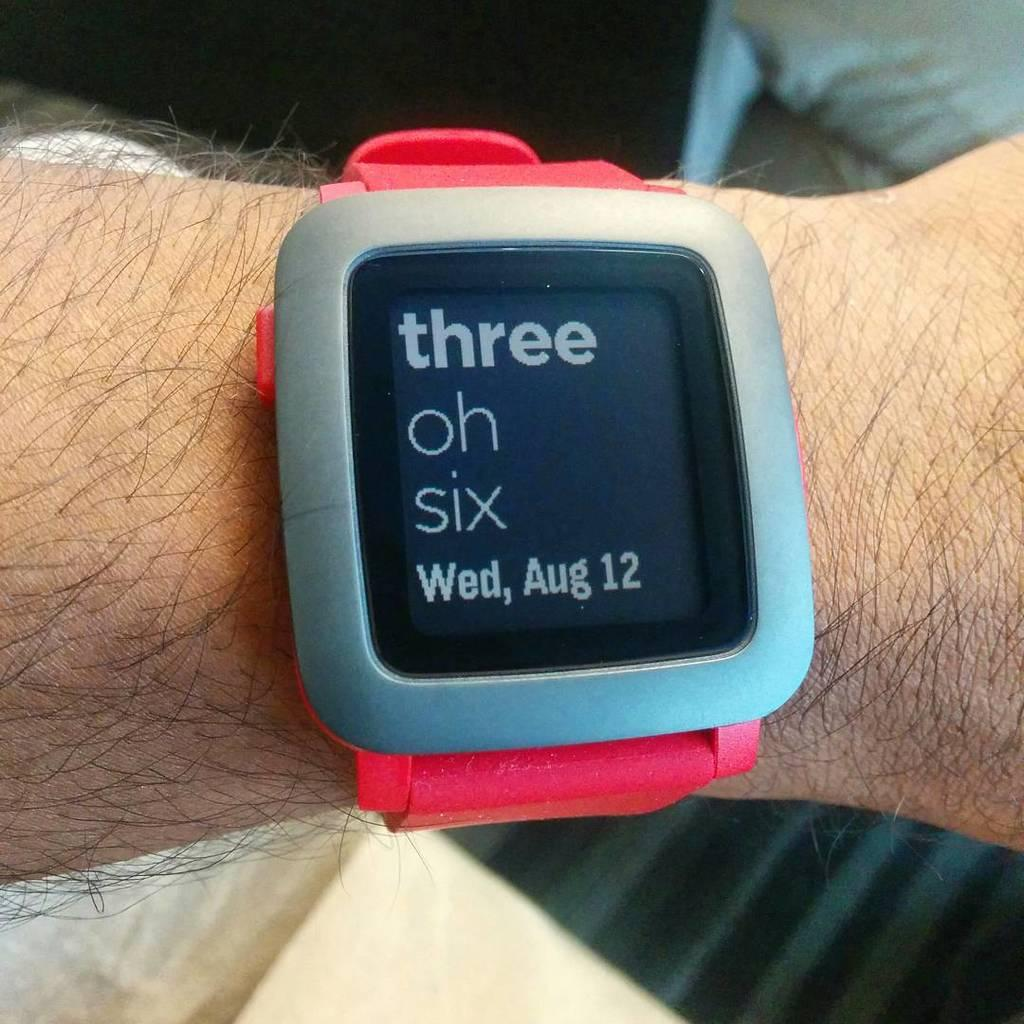<image>
Relay a brief, clear account of the picture shown. A man is wearing a pink smartwatch that says three oh six and has a pink bank. 